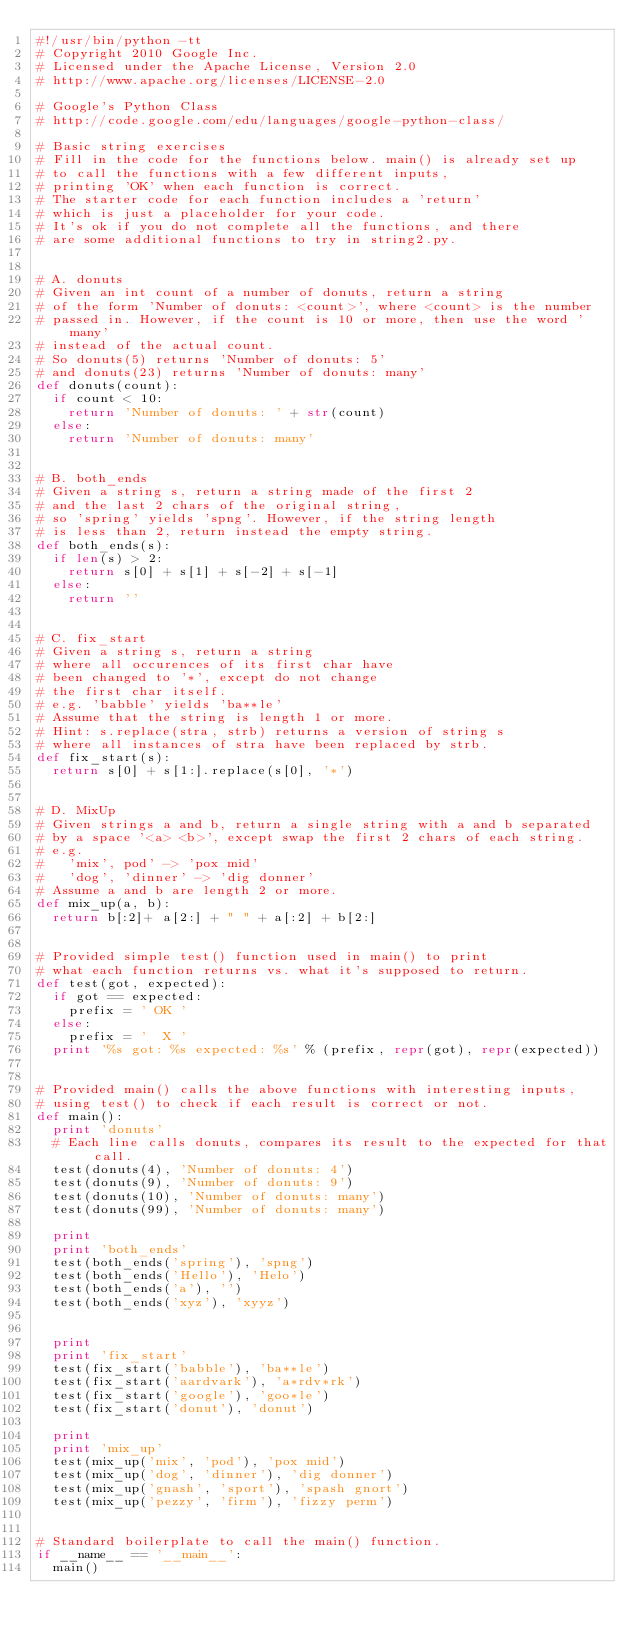<code> <loc_0><loc_0><loc_500><loc_500><_Python_>#!/usr/bin/python -tt
# Copyright 2010 Google Inc.
# Licensed under the Apache License, Version 2.0
# http://www.apache.org/licenses/LICENSE-2.0

# Google's Python Class
# http://code.google.com/edu/languages/google-python-class/

# Basic string exercises
# Fill in the code for the functions below. main() is already set up
# to call the functions with a few different inputs,
# printing 'OK' when each function is correct.
# The starter code for each function includes a 'return'
# which is just a placeholder for your code.
# It's ok if you do not complete all the functions, and there
# are some additional functions to try in string2.py.


# A. donuts
# Given an int count of a number of donuts, return a string
# of the form 'Number of donuts: <count>', where <count> is the number
# passed in. However, if the count is 10 or more, then use the word 'many'
# instead of the actual count.
# So donuts(5) returns 'Number of donuts: 5'
# and donuts(23) returns 'Number of donuts: many'
def donuts(count):
  if count < 10: 
    return 'Number of donuts: ' + str(count)
  else:
    return 'Number of donuts: many'	


# B. both_ends
# Given a string s, return a string made of the first 2
# and the last 2 chars of the original string,
# so 'spring' yields 'spng'. However, if the string length
# is less than 2, return instead the empty string.
def both_ends(s):
  if len(s) > 2:
    return s[0] + s[1] + s[-2] + s[-1]
  else:
    return ''


# C. fix_start
# Given a string s, return a string
# where all occurences of its first char have
# been changed to '*', except do not change
# the first char itself.
# e.g. 'babble' yields 'ba**le'
# Assume that the string is length 1 or more.
# Hint: s.replace(stra, strb) returns a version of string s
# where all instances of stra have been replaced by strb.
def fix_start(s):
  return s[0] + s[1:].replace(s[0], '*')


# D. MixUp
# Given strings a and b, return a single string with a and b separated
# by a space '<a> <b>', except swap the first 2 chars of each string.
# e.g.
#   'mix', pod' -> 'pox mid'
#   'dog', 'dinner' -> 'dig donner'
# Assume a and b are length 2 or more.
def mix_up(a, b):
  return b[:2]+ a[2:] + " " + a[:2] + b[2:]


# Provided simple test() function used in main() to print
# what each function returns vs. what it's supposed to return.
def test(got, expected):
  if got == expected:
    prefix = ' OK '
  else:
    prefix = '  X '
  print '%s got: %s expected: %s' % (prefix, repr(got), repr(expected))


# Provided main() calls the above functions with interesting inputs,
# using test() to check if each result is correct or not.
def main():
  print 'donuts'
  # Each line calls donuts, compares its result to the expected for that call.
  test(donuts(4), 'Number of donuts: 4')
  test(donuts(9), 'Number of donuts: 9')
  test(donuts(10), 'Number of donuts: many')
  test(donuts(99), 'Number of donuts: many')

  print
  print 'both_ends'
  test(both_ends('spring'), 'spng')
  test(both_ends('Hello'), 'Helo')
  test(both_ends('a'), '')
  test(both_ends('xyz'), 'xyyz')

  
  print
  print 'fix_start'
  test(fix_start('babble'), 'ba**le')
  test(fix_start('aardvark'), 'a*rdv*rk')
  test(fix_start('google'), 'goo*le')
  test(fix_start('donut'), 'donut')

  print
  print 'mix_up'
  test(mix_up('mix', 'pod'), 'pox mid')
  test(mix_up('dog', 'dinner'), 'dig donner')
  test(mix_up('gnash', 'sport'), 'spash gnort')
  test(mix_up('pezzy', 'firm'), 'fizzy perm')


# Standard boilerplate to call the main() function.
if __name__ == '__main__':
  main()
</code> 